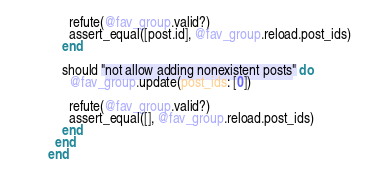Convert code to text. <code><loc_0><loc_0><loc_500><loc_500><_Ruby_>      refute(@fav_group.valid?)
      assert_equal([post.id], @fav_group.reload.post_ids)
    end

    should "not allow adding nonexistent posts" do
      @fav_group.update(post_ids: [0])

      refute(@fav_group.valid?)
      assert_equal([], @fav_group.reload.post_ids)
    end
  end
end
</code> 